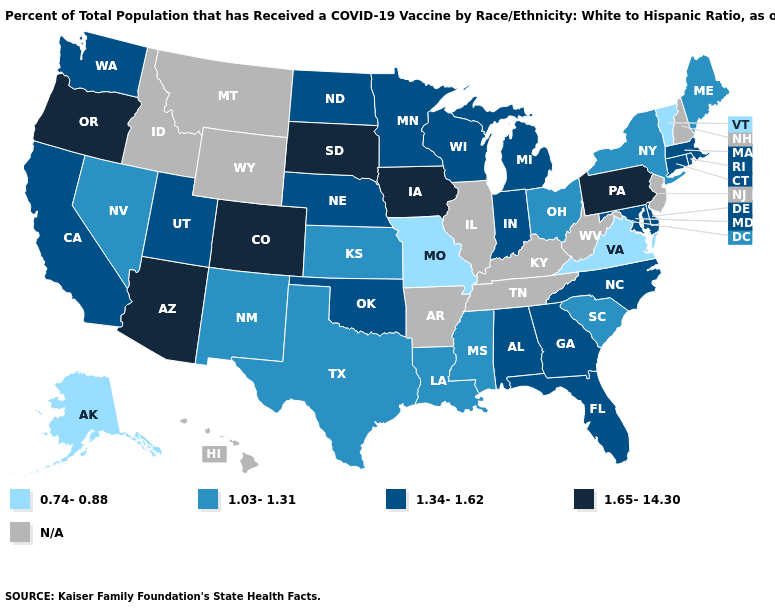How many symbols are there in the legend?
Quick response, please. 5. What is the value of Wyoming?
Give a very brief answer. N/A. Name the states that have a value in the range N/A?
Concise answer only. Arkansas, Hawaii, Idaho, Illinois, Kentucky, Montana, New Hampshire, New Jersey, Tennessee, West Virginia, Wyoming. What is the lowest value in states that border Virginia?
Answer briefly. 1.34-1.62. What is the value of Minnesota?
Write a very short answer. 1.34-1.62. Name the states that have a value in the range 1.65-14.30?
Short answer required. Arizona, Colorado, Iowa, Oregon, Pennsylvania, South Dakota. What is the value of Montana?
Concise answer only. N/A. What is the value of Nebraska?
Short answer required. 1.34-1.62. Name the states that have a value in the range N/A?
Write a very short answer. Arkansas, Hawaii, Idaho, Illinois, Kentucky, Montana, New Hampshire, New Jersey, Tennessee, West Virginia, Wyoming. Name the states that have a value in the range 1.34-1.62?
Write a very short answer. Alabama, California, Connecticut, Delaware, Florida, Georgia, Indiana, Maryland, Massachusetts, Michigan, Minnesota, Nebraska, North Carolina, North Dakota, Oklahoma, Rhode Island, Utah, Washington, Wisconsin. Among the states that border Colorado , does Kansas have the lowest value?
Give a very brief answer. Yes. What is the value of Ohio?
Keep it brief. 1.03-1.31. Among the states that border Alabama , which have the highest value?
Short answer required. Florida, Georgia. Which states hav the highest value in the West?
Write a very short answer. Arizona, Colorado, Oregon. 